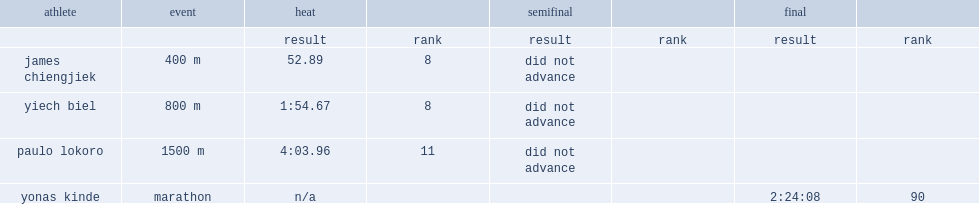What is the result of biel's raced in the 800 m, where he finished eighth in heat? 1:54.67. 